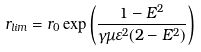<formula> <loc_0><loc_0><loc_500><loc_500>r _ { l i m } = r _ { 0 } \exp \left ( \frac { 1 - E ^ { 2 } } { \gamma \mu \varepsilon ^ { 2 } ( 2 - E ^ { 2 } ) } \right )</formula> 